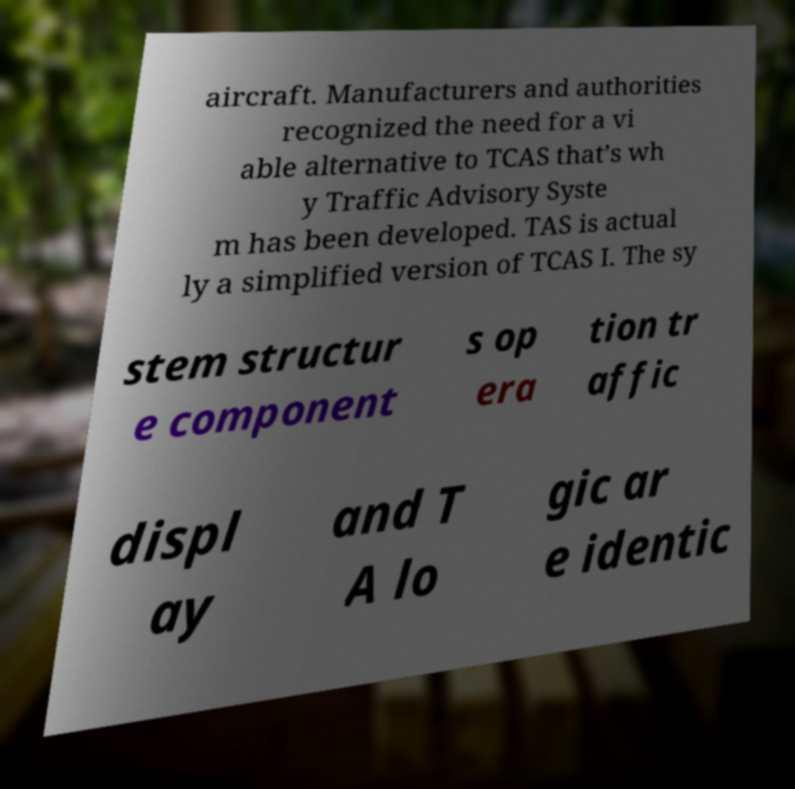For documentation purposes, I need the text within this image transcribed. Could you provide that? aircraft. Manufacturers and authorities recognized the need for a vi able alternative to TCAS that’s wh y Traffic Advisory Syste m has been developed. TAS is actual ly a simplified version of TCAS I. The sy stem structur e component s op era tion tr affic displ ay and T A lo gic ar e identic 